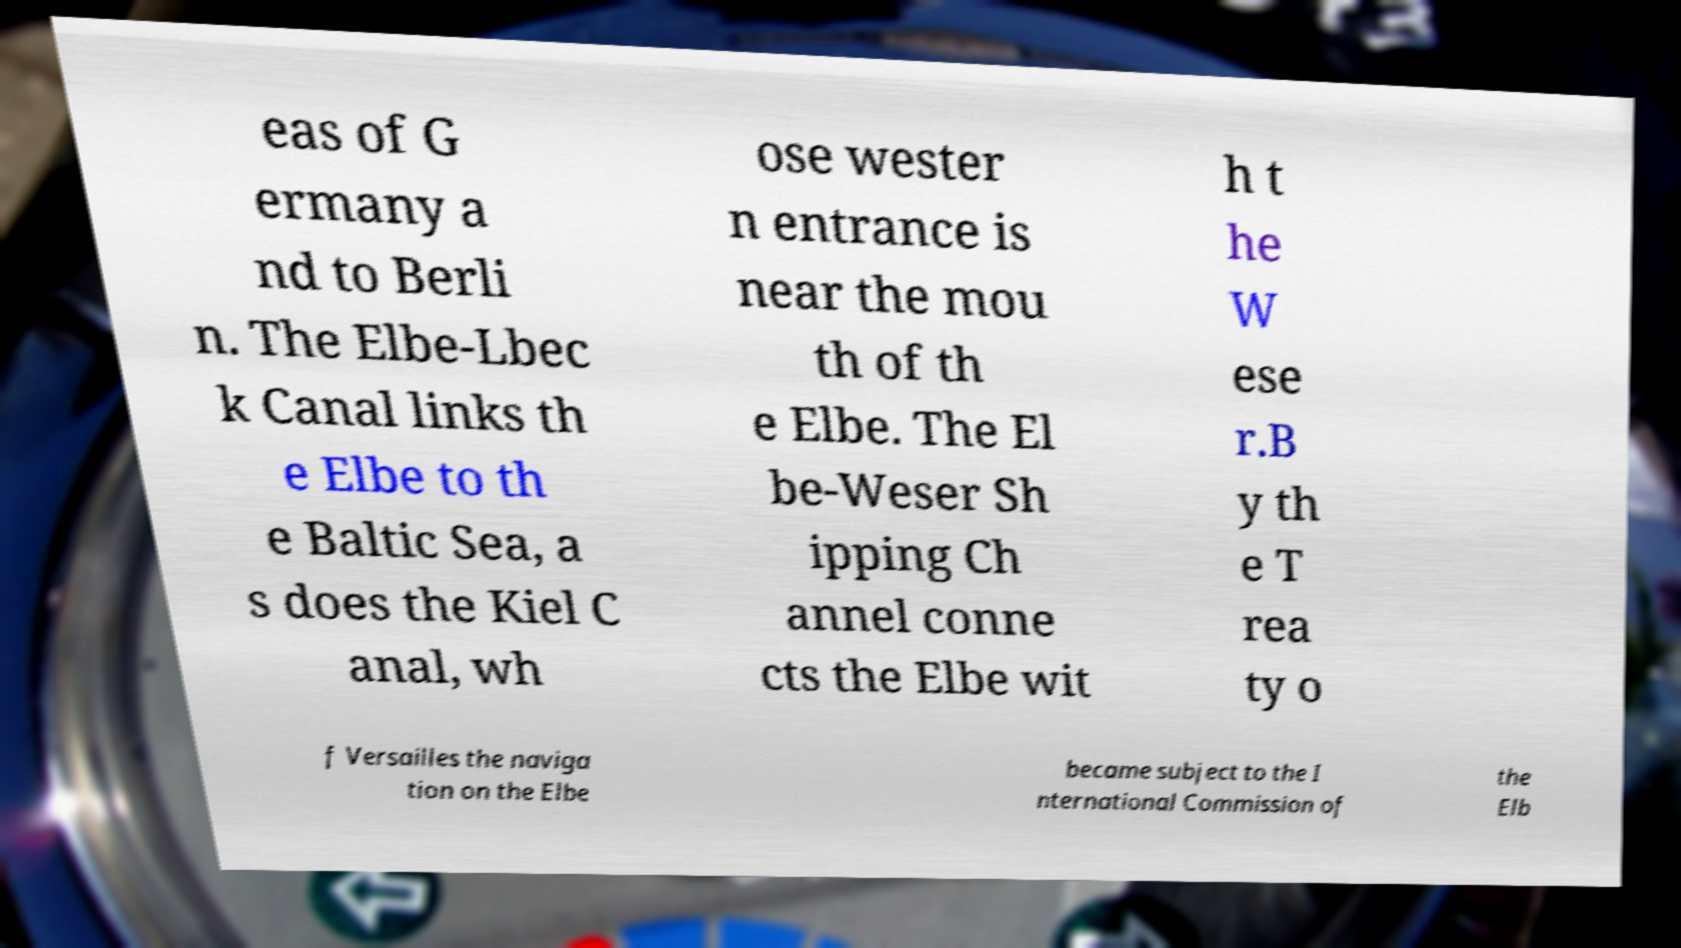Could you extract and type out the text from this image? eas of G ermany a nd to Berli n. The Elbe-Lbec k Canal links th e Elbe to th e Baltic Sea, a s does the Kiel C anal, wh ose wester n entrance is near the mou th of th e Elbe. The El be-Weser Sh ipping Ch annel conne cts the Elbe wit h t he W ese r.B y th e T rea ty o f Versailles the naviga tion on the Elbe became subject to the I nternational Commission of the Elb 